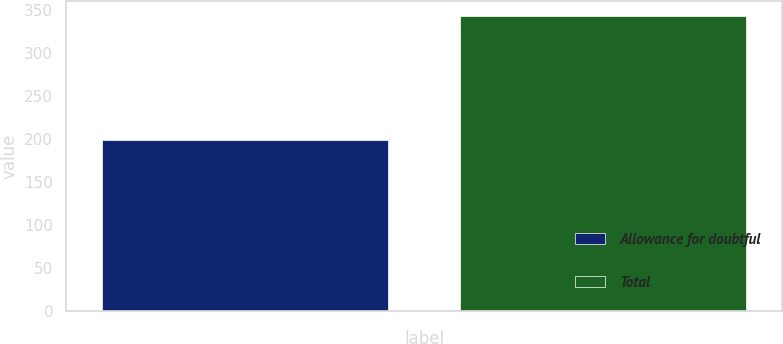Convert chart. <chart><loc_0><loc_0><loc_500><loc_500><bar_chart><fcel>Allowance for doubtful<fcel>Total<nl><fcel>199<fcel>342.8<nl></chart> 